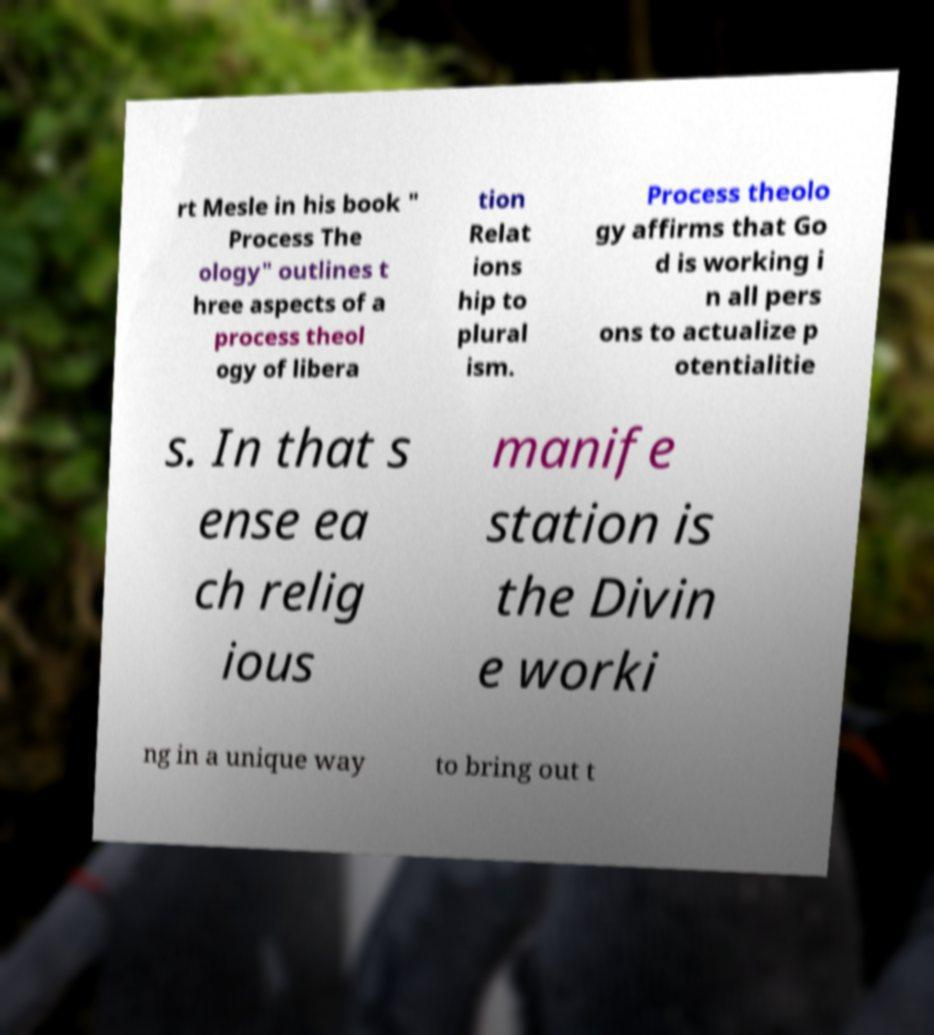Could you assist in decoding the text presented in this image and type it out clearly? rt Mesle in his book " Process The ology" outlines t hree aspects of a process theol ogy of libera tion Relat ions hip to plural ism. Process theolo gy affirms that Go d is working i n all pers ons to actualize p otentialitie s. In that s ense ea ch relig ious manife station is the Divin e worki ng in a unique way to bring out t 